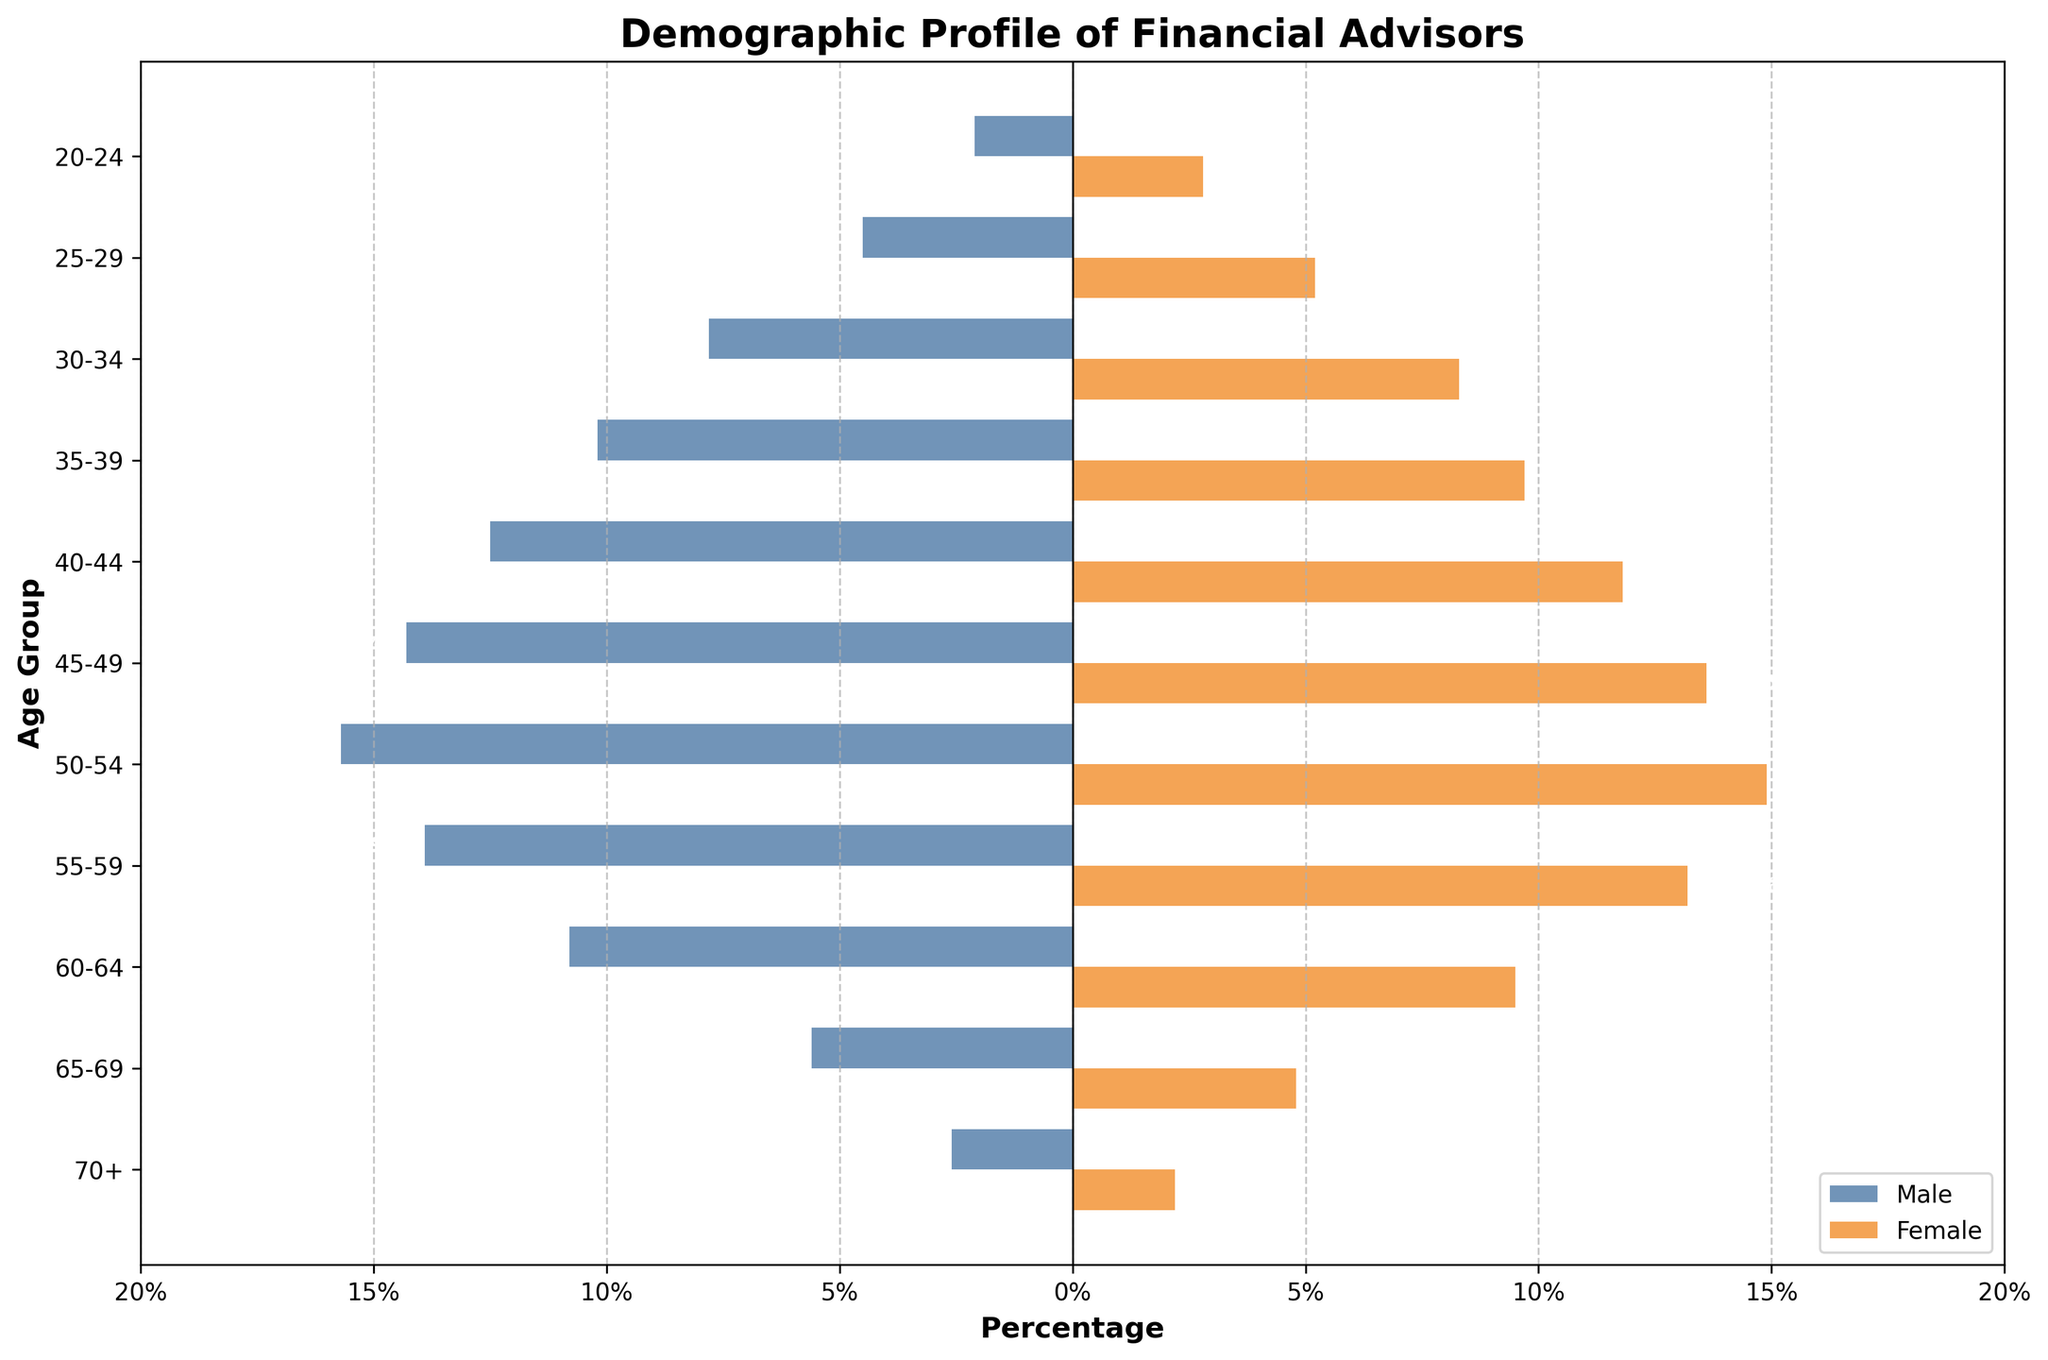What is the title of the figure? The title is usually positioned at the top of the figure and provides an overview of the displayed data. The title in this figure is "Demographic Profile of Financial Advisors".
Answer: Demographic Profile of Financial Advisors How many age groups are represented in the figure? The figure contains horizontal bars for each age group listed on the y-axis. Counting these bars will give the total number of age groups.
Answer: 11 Which age group has the highest percentage of female financial advisors? Locate the tallest bar on the right side of the plot (representing female advisors) and read the corresponding age group from the y-axis. The tallest female bar corresponds to the 30-34 age group.
Answer: 30-34 In the age group 55-59, what is the difference in percentage between male and female financial advisors? Look at the bars for the age group 55-59. The values are 13.9% for males and 13.2% for females. Subtract the female percentage from the male percentage: 
13.9% - 13.2% = 0.7%.
Answer: 0.7% Which gender has a higher percentage in the 40-44 age group? Compare the lengths of the bars for males and females in the 40-44 age group. The male bar is at 12.5% and the female bar is at 11.8%, indicating that males have a higher percentage.
Answer: Male What is the sum of the percentages of male financial advisors in the age groups 25-29 and 30-34? Find the values for the male advisors in the 25-29 and 30-34 age groups: 4.5% and 7.8%, respectively. Summing these values gives: 
4.5% + 7.8% = 12.3%.
Answer: 12.3% Which age group shows the largest difference in percentage between male and female advisors, and what is that difference? Calculate the absolute differences for each age group and identify the largest one. For instance, age group 50-54 has 15.7% males and 14.9% females, an absolute difference of 0.8%. Repeat for other age groups. The largest difference is found in the 50-54 age group with 0.8%.
Answer: 50-54, 0.8% How do the percentages of male and female advisors compare in the 70+ age group? The percentage values for the 70+ age group are 2.6% for males and 2.2% for females. This shows that there is a slightly higher percentage of male advisors in this age group.
Answer: Males slightly higher What is the average percentage of female advisors across all age groups? Sum the percentages for all age groups for females: 2.8% + 5.2% + 8.3% + 9.7% + 11.8% + 13.6% + 14.9% + 13.2% + 9.5% + 4.8% + 2.2% = 96.0%. 
Then, divide by the number of age groups (11) to get the average: 96.0% / 11 ≈ 8.7%.
Answer: 8.7% 